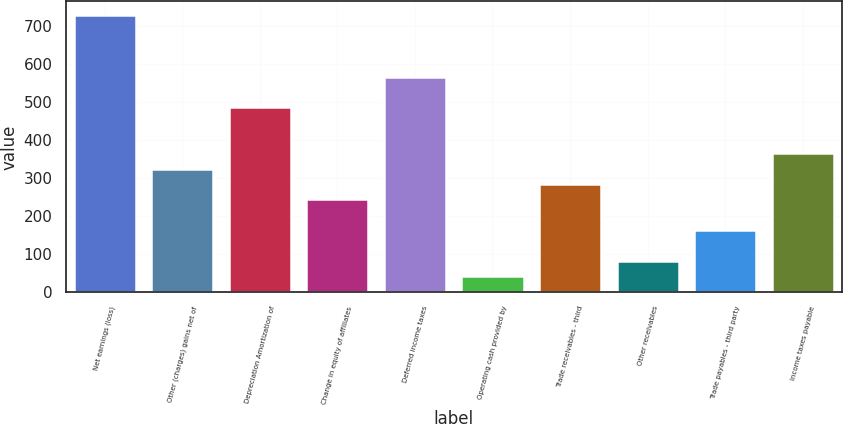<chart> <loc_0><loc_0><loc_500><loc_500><bar_chart><fcel>Net earnings (loss)<fcel>Other (charges) gains net of<fcel>Depreciation Amortization of<fcel>Change in equity of affiliates<fcel>Deferred income taxes<fcel>Operating cash provided by<fcel>Trade receivables - third<fcel>Other receivables<fcel>Trade payables - third party<fcel>Income taxes payable<nl><fcel>729.2<fcel>325.2<fcel>486.8<fcel>244.4<fcel>567.6<fcel>42.4<fcel>284.8<fcel>82.8<fcel>163.6<fcel>365.6<nl></chart> 